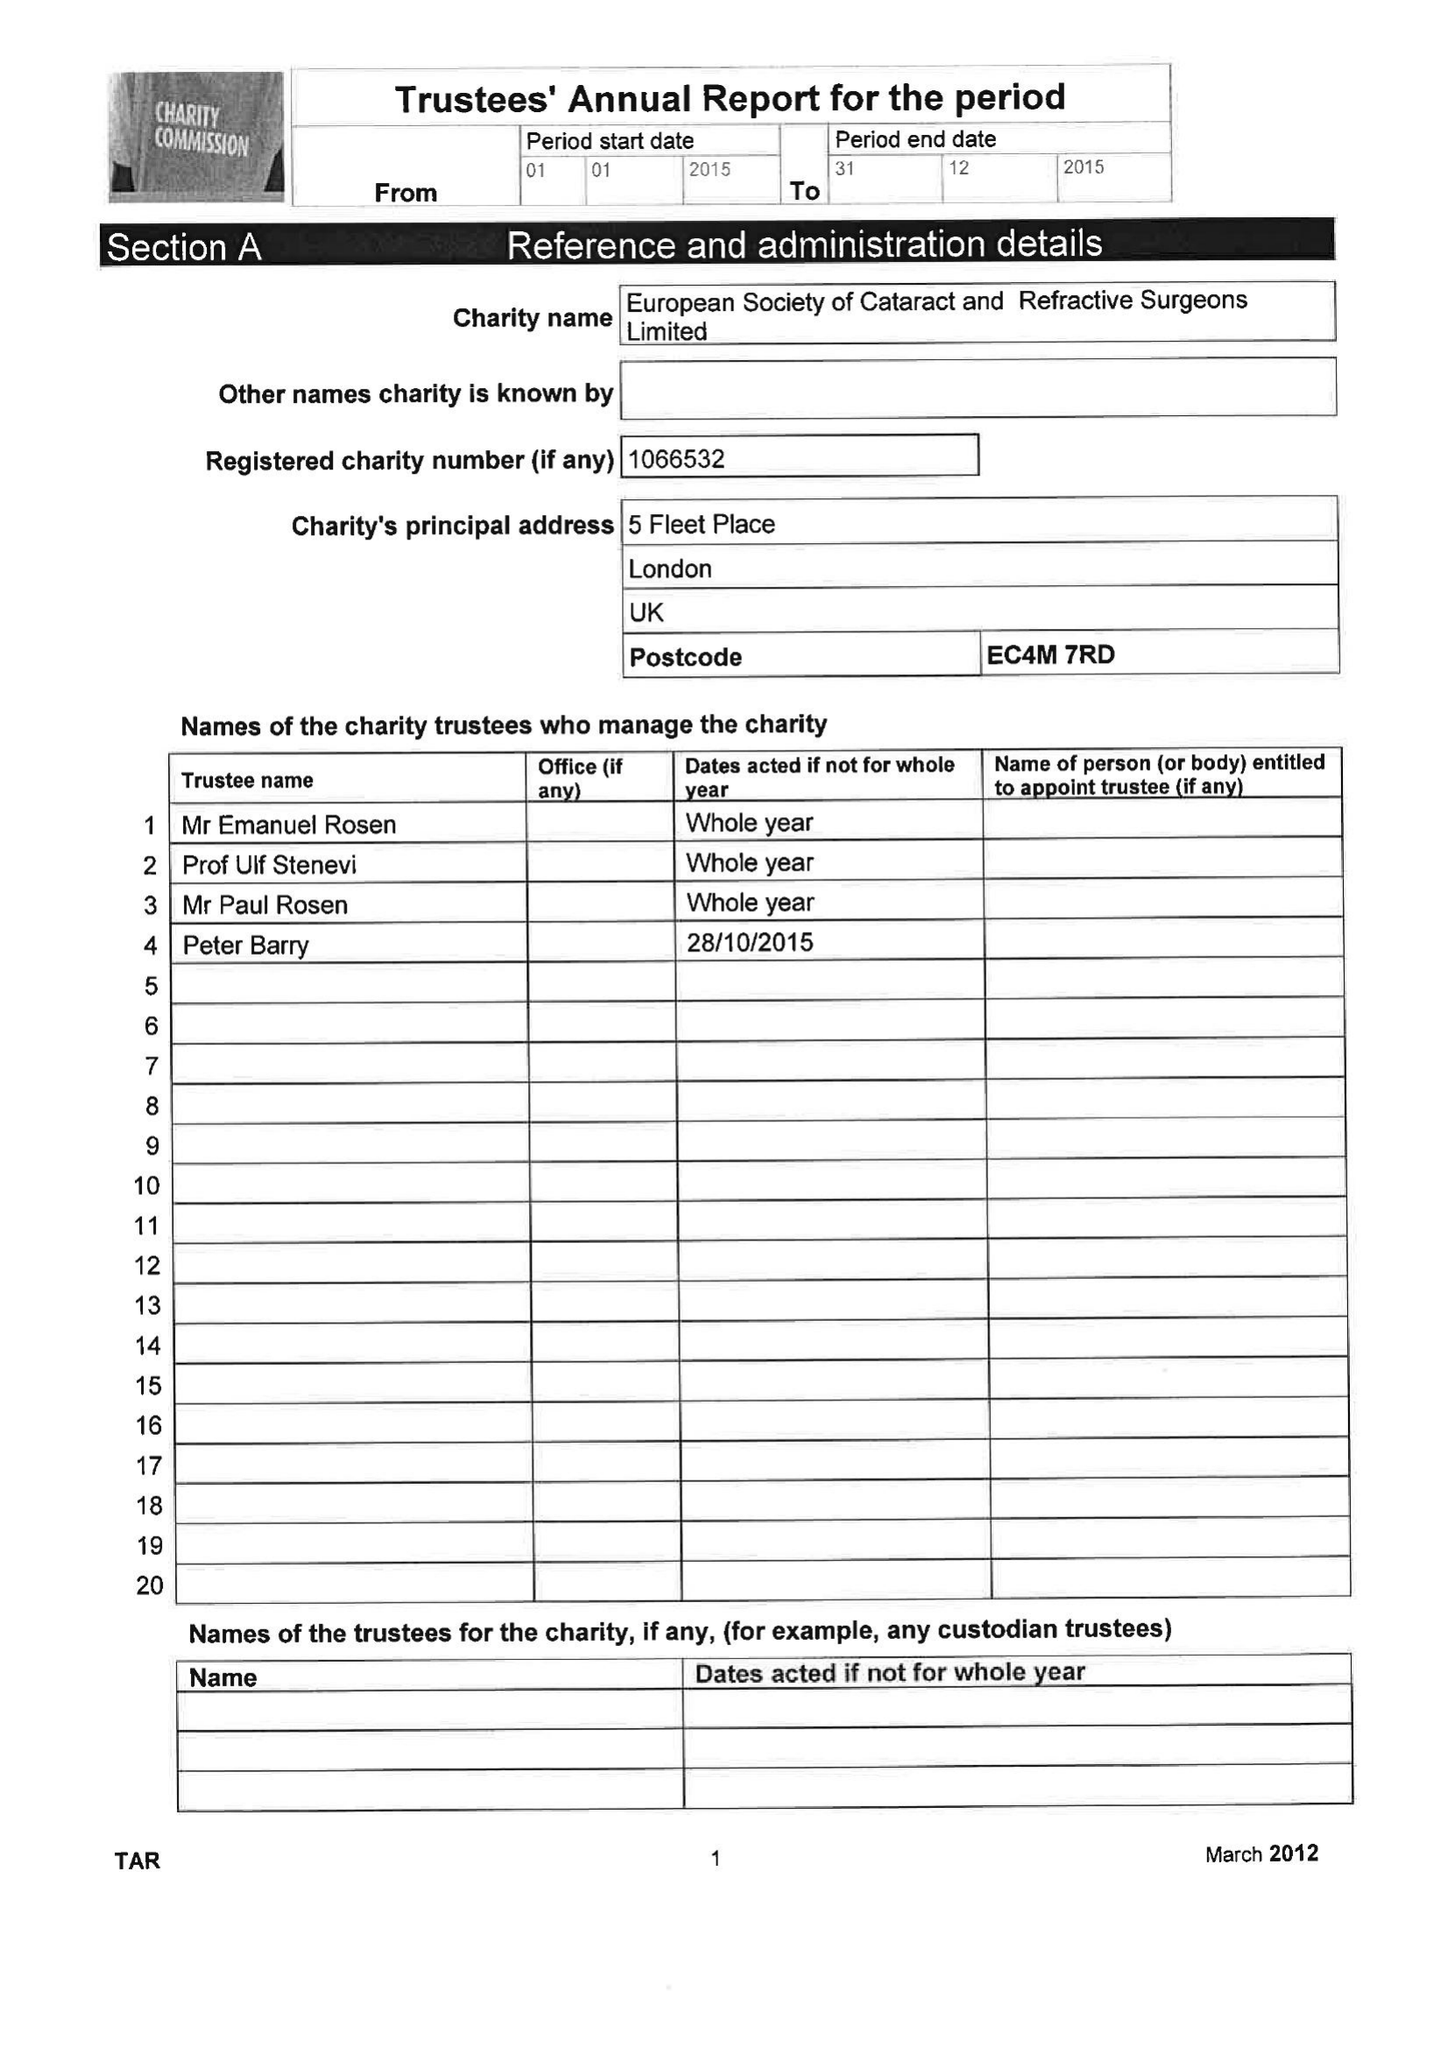What is the value for the address__post_town?
Answer the question using a single word or phrase. LONDON 